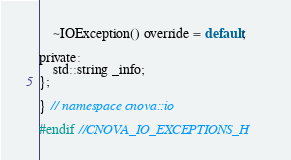<code> <loc_0><loc_0><loc_500><loc_500><_C_>    ~IOException() override = default;

private:
    std::string _info;
};

} // namespace cnova::io

#endif //CNOVA_IO_EXCEPTIONS_H
</code> 